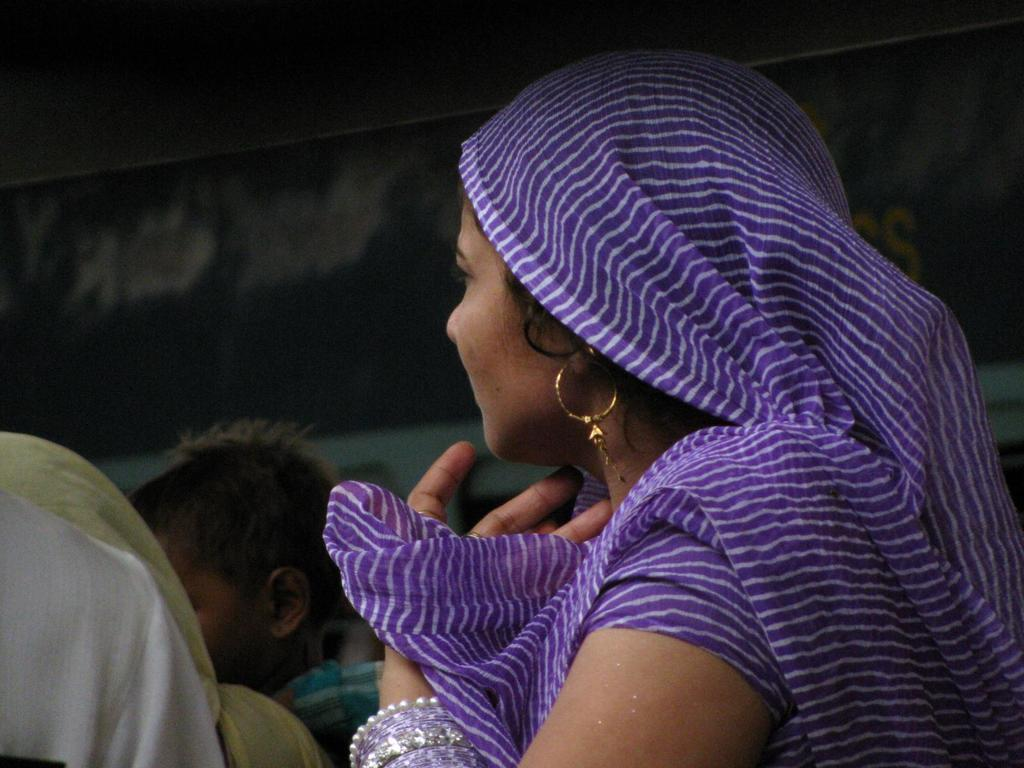What is the main subject of the image? There is a woman in the image. What accessories is the woman wearing? The woman is wearing earrings and bangles. Can you describe the people in the background of the image? There is a lady and a child in the background of the image. How would you describe the background of the image? The background of the image is blurred. What type of ear is visible on the woman in the image? There is no specific ear mentioned in the facts, and the image does not show any ears. --- Facts: 1. There is a car in the image. 2. The car is red. 3. The car has four wheels. 4. There is a road in the image. 5. The road is paved. Absurd Topics: bird, ocean, mountain Conversation: What is the main subject of the image? There is a car in the image. What color is the car? The car is red. How many wheels does the car have? The car has four wheels. What type of surface is the car on? There is a road in the image, and it is paved. Reasoning: Let's think step by step in order to produce the conversation. We start by identifying the main subject of the image, which is the car. Then, we describe the color and number of wheels of the car, as mentioned in the facts. Next, we shift our focus to the surface the car is on, mentioning the presence of a road. Finally, we describe the road, which is paved. Absurd Question/Answer: Can you see any birds flying over the ocean in the image? There is no mention of birds, ocean, or mountains in the facts, and none of these elements are present in the image. 